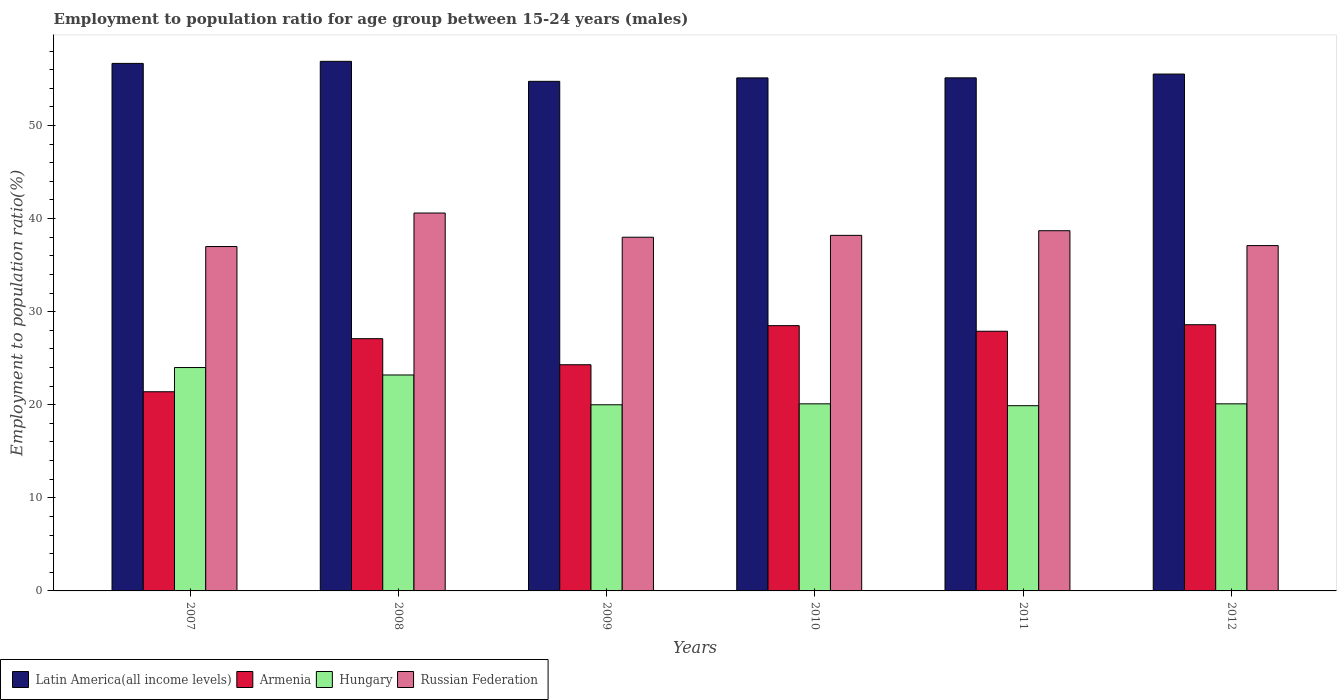How many different coloured bars are there?
Keep it short and to the point. 4. How many groups of bars are there?
Your answer should be compact. 6. Are the number of bars per tick equal to the number of legend labels?
Your answer should be very brief. Yes. How many bars are there on the 2nd tick from the left?
Keep it short and to the point. 4. How many bars are there on the 6th tick from the right?
Provide a succinct answer. 4. What is the employment to population ratio in Latin America(all income levels) in 2011?
Keep it short and to the point. 55.12. Across all years, what is the maximum employment to population ratio in Russian Federation?
Keep it short and to the point. 40.6. Across all years, what is the minimum employment to population ratio in Russian Federation?
Offer a terse response. 37. In which year was the employment to population ratio in Latin America(all income levels) maximum?
Give a very brief answer. 2008. What is the total employment to population ratio in Russian Federation in the graph?
Your response must be concise. 229.6. What is the difference between the employment to population ratio in Armenia in 2008 and that in 2010?
Keep it short and to the point. -1.4. What is the difference between the employment to population ratio in Hungary in 2007 and the employment to population ratio in Armenia in 2009?
Your answer should be compact. -0.3. What is the average employment to population ratio in Hungary per year?
Provide a short and direct response. 21.22. In the year 2011, what is the difference between the employment to population ratio in Hungary and employment to population ratio in Armenia?
Your response must be concise. -8. In how many years, is the employment to population ratio in Hungary greater than 4 %?
Your response must be concise. 6. What is the ratio of the employment to population ratio in Armenia in 2010 to that in 2011?
Your answer should be very brief. 1.02. Is the employment to population ratio in Russian Federation in 2011 less than that in 2012?
Your answer should be compact. No. Is the difference between the employment to population ratio in Hungary in 2010 and 2011 greater than the difference between the employment to population ratio in Armenia in 2010 and 2011?
Give a very brief answer. No. What is the difference between the highest and the second highest employment to population ratio in Russian Federation?
Provide a short and direct response. 1.9. What is the difference between the highest and the lowest employment to population ratio in Armenia?
Offer a very short reply. 7.2. In how many years, is the employment to population ratio in Hungary greater than the average employment to population ratio in Hungary taken over all years?
Make the answer very short. 2. Is the sum of the employment to population ratio in Russian Federation in 2008 and 2009 greater than the maximum employment to population ratio in Armenia across all years?
Offer a very short reply. Yes. Is it the case that in every year, the sum of the employment to population ratio in Armenia and employment to population ratio in Hungary is greater than the sum of employment to population ratio in Latin America(all income levels) and employment to population ratio in Russian Federation?
Give a very brief answer. No. What does the 4th bar from the left in 2008 represents?
Offer a very short reply. Russian Federation. What does the 4th bar from the right in 2008 represents?
Provide a succinct answer. Latin America(all income levels). Is it the case that in every year, the sum of the employment to population ratio in Russian Federation and employment to population ratio in Latin America(all income levels) is greater than the employment to population ratio in Hungary?
Make the answer very short. Yes. How many bars are there?
Offer a very short reply. 24. How many years are there in the graph?
Your answer should be very brief. 6. What is the difference between two consecutive major ticks on the Y-axis?
Ensure brevity in your answer.  10. Are the values on the major ticks of Y-axis written in scientific E-notation?
Provide a succinct answer. No. Where does the legend appear in the graph?
Your answer should be compact. Bottom left. How are the legend labels stacked?
Offer a terse response. Horizontal. What is the title of the graph?
Keep it short and to the point. Employment to population ratio for age group between 15-24 years (males). Does "Swaziland" appear as one of the legend labels in the graph?
Offer a very short reply. No. What is the label or title of the X-axis?
Provide a succinct answer. Years. What is the Employment to population ratio(%) of Latin America(all income levels) in 2007?
Provide a short and direct response. 56.68. What is the Employment to population ratio(%) of Armenia in 2007?
Your response must be concise. 21.4. What is the Employment to population ratio(%) of Russian Federation in 2007?
Ensure brevity in your answer.  37. What is the Employment to population ratio(%) in Latin America(all income levels) in 2008?
Ensure brevity in your answer.  56.9. What is the Employment to population ratio(%) in Armenia in 2008?
Your answer should be compact. 27.1. What is the Employment to population ratio(%) in Hungary in 2008?
Offer a very short reply. 23.2. What is the Employment to population ratio(%) of Russian Federation in 2008?
Make the answer very short. 40.6. What is the Employment to population ratio(%) in Latin America(all income levels) in 2009?
Your response must be concise. 54.75. What is the Employment to population ratio(%) of Armenia in 2009?
Provide a short and direct response. 24.3. What is the Employment to population ratio(%) in Hungary in 2009?
Your answer should be compact. 20. What is the Employment to population ratio(%) in Latin America(all income levels) in 2010?
Offer a terse response. 55.12. What is the Employment to population ratio(%) of Armenia in 2010?
Make the answer very short. 28.5. What is the Employment to population ratio(%) of Hungary in 2010?
Keep it short and to the point. 20.1. What is the Employment to population ratio(%) in Russian Federation in 2010?
Ensure brevity in your answer.  38.2. What is the Employment to population ratio(%) in Latin America(all income levels) in 2011?
Make the answer very short. 55.12. What is the Employment to population ratio(%) of Armenia in 2011?
Your response must be concise. 27.9. What is the Employment to population ratio(%) of Hungary in 2011?
Provide a succinct answer. 19.9. What is the Employment to population ratio(%) of Russian Federation in 2011?
Provide a succinct answer. 38.7. What is the Employment to population ratio(%) of Latin America(all income levels) in 2012?
Give a very brief answer. 55.53. What is the Employment to population ratio(%) of Armenia in 2012?
Offer a terse response. 28.6. What is the Employment to population ratio(%) in Hungary in 2012?
Your response must be concise. 20.1. What is the Employment to population ratio(%) in Russian Federation in 2012?
Offer a very short reply. 37.1. Across all years, what is the maximum Employment to population ratio(%) in Latin America(all income levels)?
Your answer should be very brief. 56.9. Across all years, what is the maximum Employment to population ratio(%) in Armenia?
Keep it short and to the point. 28.6. Across all years, what is the maximum Employment to population ratio(%) of Russian Federation?
Your answer should be compact. 40.6. Across all years, what is the minimum Employment to population ratio(%) of Latin America(all income levels)?
Your response must be concise. 54.75. Across all years, what is the minimum Employment to population ratio(%) in Armenia?
Your answer should be very brief. 21.4. Across all years, what is the minimum Employment to population ratio(%) in Hungary?
Offer a very short reply. 19.9. What is the total Employment to population ratio(%) of Latin America(all income levels) in the graph?
Your answer should be very brief. 334.09. What is the total Employment to population ratio(%) of Armenia in the graph?
Give a very brief answer. 157.8. What is the total Employment to population ratio(%) of Hungary in the graph?
Your answer should be compact. 127.3. What is the total Employment to population ratio(%) of Russian Federation in the graph?
Your response must be concise. 229.6. What is the difference between the Employment to population ratio(%) of Latin America(all income levels) in 2007 and that in 2008?
Offer a terse response. -0.22. What is the difference between the Employment to population ratio(%) in Latin America(all income levels) in 2007 and that in 2009?
Your answer should be very brief. 1.93. What is the difference between the Employment to population ratio(%) in Armenia in 2007 and that in 2009?
Provide a short and direct response. -2.9. What is the difference between the Employment to population ratio(%) in Hungary in 2007 and that in 2009?
Give a very brief answer. 4. What is the difference between the Employment to population ratio(%) of Russian Federation in 2007 and that in 2009?
Provide a succinct answer. -1. What is the difference between the Employment to population ratio(%) in Latin America(all income levels) in 2007 and that in 2010?
Your answer should be very brief. 1.56. What is the difference between the Employment to population ratio(%) of Latin America(all income levels) in 2007 and that in 2011?
Ensure brevity in your answer.  1.55. What is the difference between the Employment to population ratio(%) in Armenia in 2007 and that in 2011?
Give a very brief answer. -6.5. What is the difference between the Employment to population ratio(%) in Hungary in 2007 and that in 2011?
Give a very brief answer. 4.1. What is the difference between the Employment to population ratio(%) of Latin America(all income levels) in 2007 and that in 2012?
Ensure brevity in your answer.  1.14. What is the difference between the Employment to population ratio(%) of Armenia in 2007 and that in 2012?
Offer a terse response. -7.2. What is the difference between the Employment to population ratio(%) of Russian Federation in 2007 and that in 2012?
Give a very brief answer. -0.1. What is the difference between the Employment to population ratio(%) of Latin America(all income levels) in 2008 and that in 2009?
Give a very brief answer. 2.15. What is the difference between the Employment to population ratio(%) of Hungary in 2008 and that in 2009?
Offer a very short reply. 3.2. What is the difference between the Employment to population ratio(%) of Latin America(all income levels) in 2008 and that in 2010?
Give a very brief answer. 1.78. What is the difference between the Employment to population ratio(%) of Armenia in 2008 and that in 2010?
Your answer should be very brief. -1.4. What is the difference between the Employment to population ratio(%) in Russian Federation in 2008 and that in 2010?
Your response must be concise. 2.4. What is the difference between the Employment to population ratio(%) in Latin America(all income levels) in 2008 and that in 2011?
Ensure brevity in your answer.  1.77. What is the difference between the Employment to population ratio(%) of Armenia in 2008 and that in 2011?
Your answer should be compact. -0.8. What is the difference between the Employment to population ratio(%) of Hungary in 2008 and that in 2011?
Your answer should be compact. 3.3. What is the difference between the Employment to population ratio(%) of Russian Federation in 2008 and that in 2011?
Provide a short and direct response. 1.9. What is the difference between the Employment to population ratio(%) in Latin America(all income levels) in 2008 and that in 2012?
Keep it short and to the point. 1.36. What is the difference between the Employment to population ratio(%) of Latin America(all income levels) in 2009 and that in 2010?
Provide a succinct answer. -0.37. What is the difference between the Employment to population ratio(%) in Russian Federation in 2009 and that in 2010?
Offer a very short reply. -0.2. What is the difference between the Employment to population ratio(%) of Latin America(all income levels) in 2009 and that in 2011?
Give a very brief answer. -0.38. What is the difference between the Employment to population ratio(%) in Armenia in 2009 and that in 2011?
Your response must be concise. -3.6. What is the difference between the Employment to population ratio(%) in Latin America(all income levels) in 2009 and that in 2012?
Provide a short and direct response. -0.78. What is the difference between the Employment to population ratio(%) of Hungary in 2009 and that in 2012?
Your answer should be compact. -0.1. What is the difference between the Employment to population ratio(%) in Latin America(all income levels) in 2010 and that in 2011?
Give a very brief answer. -0.01. What is the difference between the Employment to population ratio(%) in Latin America(all income levels) in 2010 and that in 2012?
Your answer should be compact. -0.41. What is the difference between the Employment to population ratio(%) of Latin America(all income levels) in 2011 and that in 2012?
Provide a short and direct response. -0.41. What is the difference between the Employment to population ratio(%) in Hungary in 2011 and that in 2012?
Give a very brief answer. -0.2. What is the difference between the Employment to population ratio(%) of Russian Federation in 2011 and that in 2012?
Offer a terse response. 1.6. What is the difference between the Employment to population ratio(%) of Latin America(all income levels) in 2007 and the Employment to population ratio(%) of Armenia in 2008?
Keep it short and to the point. 29.58. What is the difference between the Employment to population ratio(%) in Latin America(all income levels) in 2007 and the Employment to population ratio(%) in Hungary in 2008?
Keep it short and to the point. 33.48. What is the difference between the Employment to population ratio(%) in Latin America(all income levels) in 2007 and the Employment to population ratio(%) in Russian Federation in 2008?
Keep it short and to the point. 16.08. What is the difference between the Employment to population ratio(%) of Armenia in 2007 and the Employment to population ratio(%) of Russian Federation in 2008?
Provide a succinct answer. -19.2. What is the difference between the Employment to population ratio(%) of Hungary in 2007 and the Employment to population ratio(%) of Russian Federation in 2008?
Give a very brief answer. -16.6. What is the difference between the Employment to population ratio(%) in Latin America(all income levels) in 2007 and the Employment to population ratio(%) in Armenia in 2009?
Your answer should be compact. 32.38. What is the difference between the Employment to population ratio(%) of Latin America(all income levels) in 2007 and the Employment to population ratio(%) of Hungary in 2009?
Provide a short and direct response. 36.68. What is the difference between the Employment to population ratio(%) of Latin America(all income levels) in 2007 and the Employment to population ratio(%) of Russian Federation in 2009?
Keep it short and to the point. 18.68. What is the difference between the Employment to population ratio(%) of Armenia in 2007 and the Employment to population ratio(%) of Russian Federation in 2009?
Keep it short and to the point. -16.6. What is the difference between the Employment to population ratio(%) of Latin America(all income levels) in 2007 and the Employment to population ratio(%) of Armenia in 2010?
Give a very brief answer. 28.18. What is the difference between the Employment to population ratio(%) in Latin America(all income levels) in 2007 and the Employment to population ratio(%) in Hungary in 2010?
Keep it short and to the point. 36.58. What is the difference between the Employment to population ratio(%) of Latin America(all income levels) in 2007 and the Employment to population ratio(%) of Russian Federation in 2010?
Offer a terse response. 18.48. What is the difference between the Employment to population ratio(%) in Armenia in 2007 and the Employment to population ratio(%) in Russian Federation in 2010?
Your answer should be very brief. -16.8. What is the difference between the Employment to population ratio(%) of Latin America(all income levels) in 2007 and the Employment to population ratio(%) of Armenia in 2011?
Your answer should be compact. 28.78. What is the difference between the Employment to population ratio(%) of Latin America(all income levels) in 2007 and the Employment to population ratio(%) of Hungary in 2011?
Your response must be concise. 36.78. What is the difference between the Employment to population ratio(%) in Latin America(all income levels) in 2007 and the Employment to population ratio(%) in Russian Federation in 2011?
Offer a very short reply. 17.98. What is the difference between the Employment to population ratio(%) of Armenia in 2007 and the Employment to population ratio(%) of Hungary in 2011?
Your answer should be very brief. 1.5. What is the difference between the Employment to population ratio(%) of Armenia in 2007 and the Employment to population ratio(%) of Russian Federation in 2011?
Provide a succinct answer. -17.3. What is the difference between the Employment to population ratio(%) of Hungary in 2007 and the Employment to population ratio(%) of Russian Federation in 2011?
Provide a short and direct response. -14.7. What is the difference between the Employment to population ratio(%) of Latin America(all income levels) in 2007 and the Employment to population ratio(%) of Armenia in 2012?
Make the answer very short. 28.08. What is the difference between the Employment to population ratio(%) in Latin America(all income levels) in 2007 and the Employment to population ratio(%) in Hungary in 2012?
Your answer should be compact. 36.58. What is the difference between the Employment to population ratio(%) in Latin America(all income levels) in 2007 and the Employment to population ratio(%) in Russian Federation in 2012?
Keep it short and to the point. 19.58. What is the difference between the Employment to population ratio(%) of Armenia in 2007 and the Employment to population ratio(%) of Russian Federation in 2012?
Offer a very short reply. -15.7. What is the difference between the Employment to population ratio(%) in Latin America(all income levels) in 2008 and the Employment to population ratio(%) in Armenia in 2009?
Your response must be concise. 32.6. What is the difference between the Employment to population ratio(%) of Latin America(all income levels) in 2008 and the Employment to population ratio(%) of Hungary in 2009?
Make the answer very short. 36.9. What is the difference between the Employment to population ratio(%) in Latin America(all income levels) in 2008 and the Employment to population ratio(%) in Russian Federation in 2009?
Offer a terse response. 18.9. What is the difference between the Employment to population ratio(%) in Hungary in 2008 and the Employment to population ratio(%) in Russian Federation in 2009?
Provide a succinct answer. -14.8. What is the difference between the Employment to population ratio(%) of Latin America(all income levels) in 2008 and the Employment to population ratio(%) of Armenia in 2010?
Offer a very short reply. 28.4. What is the difference between the Employment to population ratio(%) in Latin America(all income levels) in 2008 and the Employment to population ratio(%) in Hungary in 2010?
Provide a succinct answer. 36.8. What is the difference between the Employment to population ratio(%) in Latin America(all income levels) in 2008 and the Employment to population ratio(%) in Russian Federation in 2010?
Ensure brevity in your answer.  18.7. What is the difference between the Employment to population ratio(%) in Armenia in 2008 and the Employment to population ratio(%) in Russian Federation in 2010?
Provide a short and direct response. -11.1. What is the difference between the Employment to population ratio(%) in Latin America(all income levels) in 2008 and the Employment to population ratio(%) in Armenia in 2011?
Your response must be concise. 29. What is the difference between the Employment to population ratio(%) in Latin America(all income levels) in 2008 and the Employment to population ratio(%) in Hungary in 2011?
Provide a succinct answer. 37. What is the difference between the Employment to population ratio(%) in Latin America(all income levels) in 2008 and the Employment to population ratio(%) in Russian Federation in 2011?
Keep it short and to the point. 18.2. What is the difference between the Employment to population ratio(%) of Hungary in 2008 and the Employment to population ratio(%) of Russian Federation in 2011?
Keep it short and to the point. -15.5. What is the difference between the Employment to population ratio(%) of Latin America(all income levels) in 2008 and the Employment to population ratio(%) of Armenia in 2012?
Ensure brevity in your answer.  28.3. What is the difference between the Employment to population ratio(%) in Latin America(all income levels) in 2008 and the Employment to population ratio(%) in Hungary in 2012?
Provide a short and direct response. 36.8. What is the difference between the Employment to population ratio(%) in Latin America(all income levels) in 2008 and the Employment to population ratio(%) in Russian Federation in 2012?
Provide a succinct answer. 19.8. What is the difference between the Employment to population ratio(%) in Armenia in 2008 and the Employment to population ratio(%) in Hungary in 2012?
Make the answer very short. 7. What is the difference between the Employment to population ratio(%) of Armenia in 2008 and the Employment to population ratio(%) of Russian Federation in 2012?
Give a very brief answer. -10. What is the difference between the Employment to population ratio(%) in Latin America(all income levels) in 2009 and the Employment to population ratio(%) in Armenia in 2010?
Your answer should be very brief. 26.25. What is the difference between the Employment to population ratio(%) of Latin America(all income levels) in 2009 and the Employment to population ratio(%) of Hungary in 2010?
Provide a succinct answer. 34.65. What is the difference between the Employment to population ratio(%) in Latin America(all income levels) in 2009 and the Employment to population ratio(%) in Russian Federation in 2010?
Offer a very short reply. 16.55. What is the difference between the Employment to population ratio(%) of Armenia in 2009 and the Employment to population ratio(%) of Hungary in 2010?
Make the answer very short. 4.2. What is the difference between the Employment to population ratio(%) of Armenia in 2009 and the Employment to population ratio(%) of Russian Federation in 2010?
Offer a terse response. -13.9. What is the difference between the Employment to population ratio(%) of Hungary in 2009 and the Employment to population ratio(%) of Russian Federation in 2010?
Your answer should be compact. -18.2. What is the difference between the Employment to population ratio(%) in Latin America(all income levels) in 2009 and the Employment to population ratio(%) in Armenia in 2011?
Ensure brevity in your answer.  26.85. What is the difference between the Employment to population ratio(%) in Latin America(all income levels) in 2009 and the Employment to population ratio(%) in Hungary in 2011?
Your response must be concise. 34.85. What is the difference between the Employment to population ratio(%) in Latin America(all income levels) in 2009 and the Employment to population ratio(%) in Russian Federation in 2011?
Keep it short and to the point. 16.05. What is the difference between the Employment to population ratio(%) of Armenia in 2009 and the Employment to population ratio(%) of Hungary in 2011?
Make the answer very short. 4.4. What is the difference between the Employment to population ratio(%) in Armenia in 2009 and the Employment to population ratio(%) in Russian Federation in 2011?
Keep it short and to the point. -14.4. What is the difference between the Employment to population ratio(%) in Hungary in 2009 and the Employment to population ratio(%) in Russian Federation in 2011?
Give a very brief answer. -18.7. What is the difference between the Employment to population ratio(%) in Latin America(all income levels) in 2009 and the Employment to population ratio(%) in Armenia in 2012?
Make the answer very short. 26.15. What is the difference between the Employment to population ratio(%) in Latin America(all income levels) in 2009 and the Employment to population ratio(%) in Hungary in 2012?
Your answer should be very brief. 34.65. What is the difference between the Employment to population ratio(%) of Latin America(all income levels) in 2009 and the Employment to population ratio(%) of Russian Federation in 2012?
Offer a very short reply. 17.65. What is the difference between the Employment to population ratio(%) of Hungary in 2009 and the Employment to population ratio(%) of Russian Federation in 2012?
Offer a terse response. -17.1. What is the difference between the Employment to population ratio(%) in Latin America(all income levels) in 2010 and the Employment to population ratio(%) in Armenia in 2011?
Your response must be concise. 27.22. What is the difference between the Employment to population ratio(%) of Latin America(all income levels) in 2010 and the Employment to population ratio(%) of Hungary in 2011?
Give a very brief answer. 35.22. What is the difference between the Employment to population ratio(%) of Latin America(all income levels) in 2010 and the Employment to population ratio(%) of Russian Federation in 2011?
Provide a short and direct response. 16.42. What is the difference between the Employment to population ratio(%) of Armenia in 2010 and the Employment to population ratio(%) of Hungary in 2011?
Keep it short and to the point. 8.6. What is the difference between the Employment to population ratio(%) in Armenia in 2010 and the Employment to population ratio(%) in Russian Federation in 2011?
Your answer should be compact. -10.2. What is the difference between the Employment to population ratio(%) in Hungary in 2010 and the Employment to population ratio(%) in Russian Federation in 2011?
Your answer should be very brief. -18.6. What is the difference between the Employment to population ratio(%) in Latin America(all income levels) in 2010 and the Employment to population ratio(%) in Armenia in 2012?
Your answer should be compact. 26.52. What is the difference between the Employment to population ratio(%) in Latin America(all income levels) in 2010 and the Employment to population ratio(%) in Hungary in 2012?
Your answer should be compact. 35.02. What is the difference between the Employment to population ratio(%) of Latin America(all income levels) in 2010 and the Employment to population ratio(%) of Russian Federation in 2012?
Your response must be concise. 18.02. What is the difference between the Employment to population ratio(%) in Armenia in 2010 and the Employment to population ratio(%) in Russian Federation in 2012?
Provide a short and direct response. -8.6. What is the difference between the Employment to population ratio(%) of Hungary in 2010 and the Employment to population ratio(%) of Russian Federation in 2012?
Keep it short and to the point. -17. What is the difference between the Employment to population ratio(%) of Latin America(all income levels) in 2011 and the Employment to population ratio(%) of Armenia in 2012?
Provide a short and direct response. 26.52. What is the difference between the Employment to population ratio(%) in Latin America(all income levels) in 2011 and the Employment to population ratio(%) in Hungary in 2012?
Offer a terse response. 35.02. What is the difference between the Employment to population ratio(%) in Latin America(all income levels) in 2011 and the Employment to population ratio(%) in Russian Federation in 2012?
Make the answer very short. 18.02. What is the difference between the Employment to population ratio(%) in Armenia in 2011 and the Employment to population ratio(%) in Hungary in 2012?
Offer a terse response. 7.8. What is the difference between the Employment to population ratio(%) in Hungary in 2011 and the Employment to population ratio(%) in Russian Federation in 2012?
Offer a terse response. -17.2. What is the average Employment to population ratio(%) in Latin America(all income levels) per year?
Your answer should be very brief. 55.68. What is the average Employment to population ratio(%) in Armenia per year?
Make the answer very short. 26.3. What is the average Employment to population ratio(%) of Hungary per year?
Offer a terse response. 21.22. What is the average Employment to population ratio(%) in Russian Federation per year?
Provide a short and direct response. 38.27. In the year 2007, what is the difference between the Employment to population ratio(%) in Latin America(all income levels) and Employment to population ratio(%) in Armenia?
Your response must be concise. 35.28. In the year 2007, what is the difference between the Employment to population ratio(%) in Latin America(all income levels) and Employment to population ratio(%) in Hungary?
Keep it short and to the point. 32.68. In the year 2007, what is the difference between the Employment to population ratio(%) in Latin America(all income levels) and Employment to population ratio(%) in Russian Federation?
Ensure brevity in your answer.  19.68. In the year 2007, what is the difference between the Employment to population ratio(%) in Armenia and Employment to population ratio(%) in Russian Federation?
Your answer should be compact. -15.6. In the year 2008, what is the difference between the Employment to population ratio(%) of Latin America(all income levels) and Employment to population ratio(%) of Armenia?
Provide a short and direct response. 29.8. In the year 2008, what is the difference between the Employment to population ratio(%) of Latin America(all income levels) and Employment to population ratio(%) of Hungary?
Provide a succinct answer. 33.7. In the year 2008, what is the difference between the Employment to population ratio(%) in Latin America(all income levels) and Employment to population ratio(%) in Russian Federation?
Your answer should be compact. 16.3. In the year 2008, what is the difference between the Employment to population ratio(%) of Hungary and Employment to population ratio(%) of Russian Federation?
Your response must be concise. -17.4. In the year 2009, what is the difference between the Employment to population ratio(%) of Latin America(all income levels) and Employment to population ratio(%) of Armenia?
Give a very brief answer. 30.45. In the year 2009, what is the difference between the Employment to population ratio(%) of Latin America(all income levels) and Employment to population ratio(%) of Hungary?
Provide a short and direct response. 34.75. In the year 2009, what is the difference between the Employment to population ratio(%) of Latin America(all income levels) and Employment to population ratio(%) of Russian Federation?
Your response must be concise. 16.75. In the year 2009, what is the difference between the Employment to population ratio(%) of Armenia and Employment to population ratio(%) of Hungary?
Offer a very short reply. 4.3. In the year 2009, what is the difference between the Employment to population ratio(%) in Armenia and Employment to population ratio(%) in Russian Federation?
Provide a short and direct response. -13.7. In the year 2010, what is the difference between the Employment to population ratio(%) of Latin America(all income levels) and Employment to population ratio(%) of Armenia?
Make the answer very short. 26.62. In the year 2010, what is the difference between the Employment to population ratio(%) in Latin America(all income levels) and Employment to population ratio(%) in Hungary?
Offer a very short reply. 35.02. In the year 2010, what is the difference between the Employment to population ratio(%) of Latin America(all income levels) and Employment to population ratio(%) of Russian Federation?
Your answer should be very brief. 16.92. In the year 2010, what is the difference between the Employment to population ratio(%) in Armenia and Employment to population ratio(%) in Russian Federation?
Your answer should be very brief. -9.7. In the year 2010, what is the difference between the Employment to population ratio(%) in Hungary and Employment to population ratio(%) in Russian Federation?
Offer a very short reply. -18.1. In the year 2011, what is the difference between the Employment to population ratio(%) in Latin America(all income levels) and Employment to population ratio(%) in Armenia?
Give a very brief answer. 27.22. In the year 2011, what is the difference between the Employment to population ratio(%) in Latin America(all income levels) and Employment to population ratio(%) in Hungary?
Provide a succinct answer. 35.22. In the year 2011, what is the difference between the Employment to population ratio(%) of Latin America(all income levels) and Employment to population ratio(%) of Russian Federation?
Make the answer very short. 16.42. In the year 2011, what is the difference between the Employment to population ratio(%) of Hungary and Employment to population ratio(%) of Russian Federation?
Keep it short and to the point. -18.8. In the year 2012, what is the difference between the Employment to population ratio(%) in Latin America(all income levels) and Employment to population ratio(%) in Armenia?
Your response must be concise. 26.93. In the year 2012, what is the difference between the Employment to population ratio(%) in Latin America(all income levels) and Employment to population ratio(%) in Hungary?
Provide a succinct answer. 35.43. In the year 2012, what is the difference between the Employment to population ratio(%) in Latin America(all income levels) and Employment to population ratio(%) in Russian Federation?
Give a very brief answer. 18.43. What is the ratio of the Employment to population ratio(%) of Armenia in 2007 to that in 2008?
Keep it short and to the point. 0.79. What is the ratio of the Employment to population ratio(%) in Hungary in 2007 to that in 2008?
Your response must be concise. 1.03. What is the ratio of the Employment to population ratio(%) of Russian Federation in 2007 to that in 2008?
Offer a terse response. 0.91. What is the ratio of the Employment to population ratio(%) of Latin America(all income levels) in 2007 to that in 2009?
Offer a very short reply. 1.04. What is the ratio of the Employment to population ratio(%) in Armenia in 2007 to that in 2009?
Make the answer very short. 0.88. What is the ratio of the Employment to population ratio(%) of Hungary in 2007 to that in 2009?
Provide a succinct answer. 1.2. What is the ratio of the Employment to population ratio(%) of Russian Federation in 2007 to that in 2009?
Offer a terse response. 0.97. What is the ratio of the Employment to population ratio(%) of Latin America(all income levels) in 2007 to that in 2010?
Your response must be concise. 1.03. What is the ratio of the Employment to population ratio(%) in Armenia in 2007 to that in 2010?
Make the answer very short. 0.75. What is the ratio of the Employment to population ratio(%) in Hungary in 2007 to that in 2010?
Make the answer very short. 1.19. What is the ratio of the Employment to population ratio(%) in Russian Federation in 2007 to that in 2010?
Provide a succinct answer. 0.97. What is the ratio of the Employment to population ratio(%) of Latin America(all income levels) in 2007 to that in 2011?
Offer a very short reply. 1.03. What is the ratio of the Employment to population ratio(%) of Armenia in 2007 to that in 2011?
Your answer should be very brief. 0.77. What is the ratio of the Employment to population ratio(%) in Hungary in 2007 to that in 2011?
Provide a short and direct response. 1.21. What is the ratio of the Employment to population ratio(%) in Russian Federation in 2007 to that in 2011?
Your answer should be very brief. 0.96. What is the ratio of the Employment to population ratio(%) of Latin America(all income levels) in 2007 to that in 2012?
Keep it short and to the point. 1.02. What is the ratio of the Employment to population ratio(%) in Armenia in 2007 to that in 2012?
Ensure brevity in your answer.  0.75. What is the ratio of the Employment to population ratio(%) of Hungary in 2007 to that in 2012?
Provide a short and direct response. 1.19. What is the ratio of the Employment to population ratio(%) in Russian Federation in 2007 to that in 2012?
Offer a very short reply. 1. What is the ratio of the Employment to population ratio(%) of Latin America(all income levels) in 2008 to that in 2009?
Your answer should be compact. 1.04. What is the ratio of the Employment to population ratio(%) in Armenia in 2008 to that in 2009?
Your response must be concise. 1.12. What is the ratio of the Employment to population ratio(%) in Hungary in 2008 to that in 2009?
Keep it short and to the point. 1.16. What is the ratio of the Employment to population ratio(%) of Russian Federation in 2008 to that in 2009?
Offer a terse response. 1.07. What is the ratio of the Employment to population ratio(%) in Latin America(all income levels) in 2008 to that in 2010?
Provide a short and direct response. 1.03. What is the ratio of the Employment to population ratio(%) of Armenia in 2008 to that in 2010?
Your response must be concise. 0.95. What is the ratio of the Employment to population ratio(%) of Hungary in 2008 to that in 2010?
Provide a short and direct response. 1.15. What is the ratio of the Employment to population ratio(%) in Russian Federation in 2008 to that in 2010?
Your response must be concise. 1.06. What is the ratio of the Employment to population ratio(%) in Latin America(all income levels) in 2008 to that in 2011?
Your answer should be very brief. 1.03. What is the ratio of the Employment to population ratio(%) in Armenia in 2008 to that in 2011?
Offer a terse response. 0.97. What is the ratio of the Employment to population ratio(%) of Hungary in 2008 to that in 2011?
Provide a short and direct response. 1.17. What is the ratio of the Employment to population ratio(%) in Russian Federation in 2008 to that in 2011?
Your answer should be compact. 1.05. What is the ratio of the Employment to population ratio(%) in Latin America(all income levels) in 2008 to that in 2012?
Offer a very short reply. 1.02. What is the ratio of the Employment to population ratio(%) in Armenia in 2008 to that in 2012?
Offer a terse response. 0.95. What is the ratio of the Employment to population ratio(%) of Hungary in 2008 to that in 2012?
Make the answer very short. 1.15. What is the ratio of the Employment to population ratio(%) of Russian Federation in 2008 to that in 2012?
Ensure brevity in your answer.  1.09. What is the ratio of the Employment to population ratio(%) in Armenia in 2009 to that in 2010?
Your answer should be very brief. 0.85. What is the ratio of the Employment to population ratio(%) in Latin America(all income levels) in 2009 to that in 2011?
Offer a terse response. 0.99. What is the ratio of the Employment to population ratio(%) of Armenia in 2009 to that in 2011?
Offer a very short reply. 0.87. What is the ratio of the Employment to population ratio(%) in Russian Federation in 2009 to that in 2011?
Give a very brief answer. 0.98. What is the ratio of the Employment to population ratio(%) of Latin America(all income levels) in 2009 to that in 2012?
Your answer should be compact. 0.99. What is the ratio of the Employment to population ratio(%) in Armenia in 2009 to that in 2012?
Your answer should be compact. 0.85. What is the ratio of the Employment to population ratio(%) in Hungary in 2009 to that in 2012?
Your answer should be compact. 0.99. What is the ratio of the Employment to population ratio(%) of Russian Federation in 2009 to that in 2012?
Give a very brief answer. 1.02. What is the ratio of the Employment to population ratio(%) of Armenia in 2010 to that in 2011?
Ensure brevity in your answer.  1.02. What is the ratio of the Employment to population ratio(%) of Russian Federation in 2010 to that in 2011?
Your answer should be compact. 0.99. What is the ratio of the Employment to population ratio(%) in Latin America(all income levels) in 2010 to that in 2012?
Make the answer very short. 0.99. What is the ratio of the Employment to population ratio(%) of Armenia in 2010 to that in 2012?
Provide a succinct answer. 1. What is the ratio of the Employment to population ratio(%) of Russian Federation in 2010 to that in 2012?
Provide a succinct answer. 1.03. What is the ratio of the Employment to population ratio(%) in Armenia in 2011 to that in 2012?
Ensure brevity in your answer.  0.98. What is the ratio of the Employment to population ratio(%) of Hungary in 2011 to that in 2012?
Give a very brief answer. 0.99. What is the ratio of the Employment to population ratio(%) of Russian Federation in 2011 to that in 2012?
Give a very brief answer. 1.04. What is the difference between the highest and the second highest Employment to population ratio(%) of Latin America(all income levels)?
Offer a terse response. 0.22. What is the difference between the highest and the second highest Employment to population ratio(%) in Armenia?
Your response must be concise. 0.1. What is the difference between the highest and the second highest Employment to population ratio(%) in Russian Federation?
Your answer should be very brief. 1.9. What is the difference between the highest and the lowest Employment to population ratio(%) of Latin America(all income levels)?
Your response must be concise. 2.15. What is the difference between the highest and the lowest Employment to population ratio(%) in Hungary?
Offer a very short reply. 4.1. 